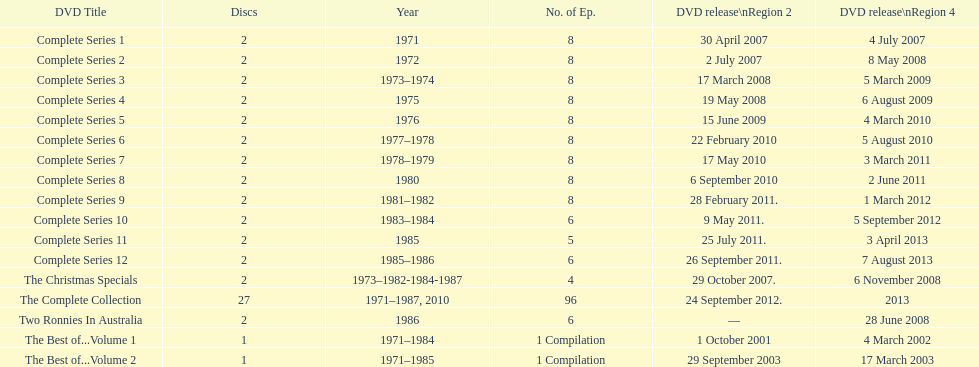How many "best of" volumes compile the top episodes of the television show "the two ronnies". 2. 